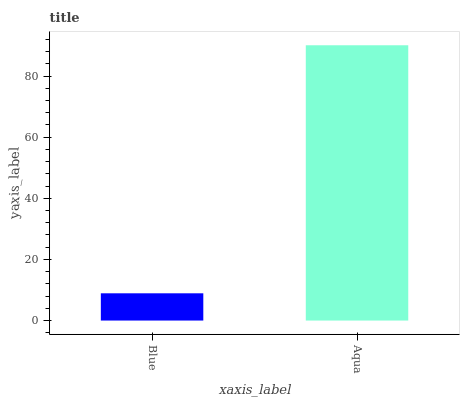Is Blue the minimum?
Answer yes or no. Yes. Is Aqua the maximum?
Answer yes or no. Yes. Is Aqua the minimum?
Answer yes or no. No. Is Aqua greater than Blue?
Answer yes or no. Yes. Is Blue less than Aqua?
Answer yes or no. Yes. Is Blue greater than Aqua?
Answer yes or no. No. Is Aqua less than Blue?
Answer yes or no. No. Is Aqua the high median?
Answer yes or no. Yes. Is Blue the low median?
Answer yes or no. Yes. Is Blue the high median?
Answer yes or no. No. Is Aqua the low median?
Answer yes or no. No. 